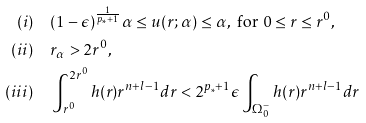Convert formula to latex. <formula><loc_0><loc_0><loc_500><loc_500>( i ) & \quad ( 1 - \epsilon ) ^ { \frac { 1 } { p _ { \ast } + 1 } } \alpha \leq u ( r ; \alpha ) \leq \alpha , \text { for } 0 \leq r \leq r ^ { 0 } , \\ ( i i ) & \quad r _ { \alpha } > 2 r ^ { 0 } , \\ ( i i i ) & \quad \int _ { r ^ { 0 } } ^ { 2 r ^ { 0 } } h ( r ) r ^ { n + l - 1 } d r < 2 ^ { p _ { \ast } + 1 } \epsilon \int _ { \Omega _ { 0 } ^ { - } } h ( r ) r ^ { n + l - 1 } d r</formula> 